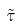Convert formula to latex. <formula><loc_0><loc_0><loc_500><loc_500>\tilde { \tau }</formula> 